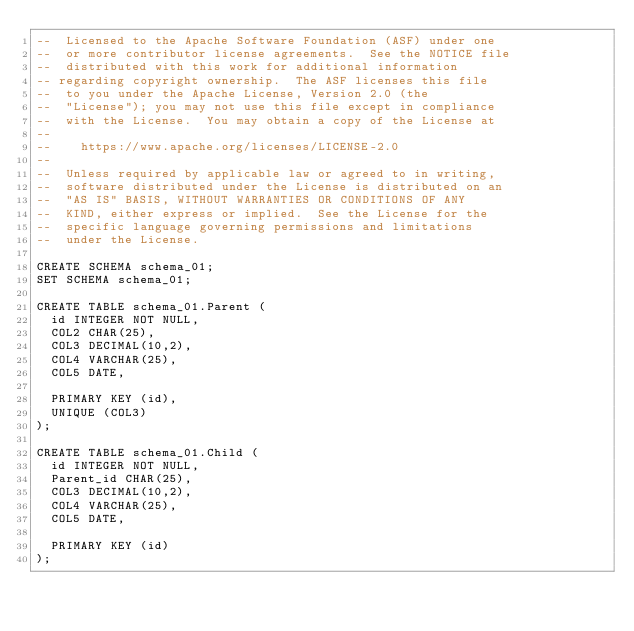Convert code to text. <code><loc_0><loc_0><loc_500><loc_500><_SQL_>--  Licensed to the Apache Software Foundation (ASF) under one
--  or more contributor license agreements.  See the NOTICE file
--  distributed with this work for additional information
-- regarding copyright ownership.  The ASF licenses this file
--  to you under the Apache License, Version 2.0 (the
--  "License"); you may not use this file except in compliance
--  with the License.  You may obtain a copy of the License at
--
--    https://www.apache.org/licenses/LICENSE-2.0
--
--  Unless required by applicable law or agreed to in writing,
--  software distributed under the License is distributed on an
--  "AS IS" BASIS, WITHOUT WARRANTIES OR CONDITIONS OF ANY
--  KIND, either express or implied.  See the License for the
--  specific language governing permissions and limitations
--  under the License.

CREATE SCHEMA schema_01;
SET SCHEMA schema_01;

CREATE TABLE schema_01.Parent (
  id INTEGER NOT NULL,
  COL2 CHAR(25),
  COL3 DECIMAL(10,2),
  COL4 VARCHAR(25),
  COL5 DATE,

  PRIMARY KEY (id),
  UNIQUE (COL3)
);

CREATE TABLE schema_01.Child (
  id INTEGER NOT NULL,
  Parent_id CHAR(25),
  COL3 DECIMAL(10,2),
  COL4 VARCHAR(25),
  COL5 DATE,

  PRIMARY KEY (id)
);
</code> 